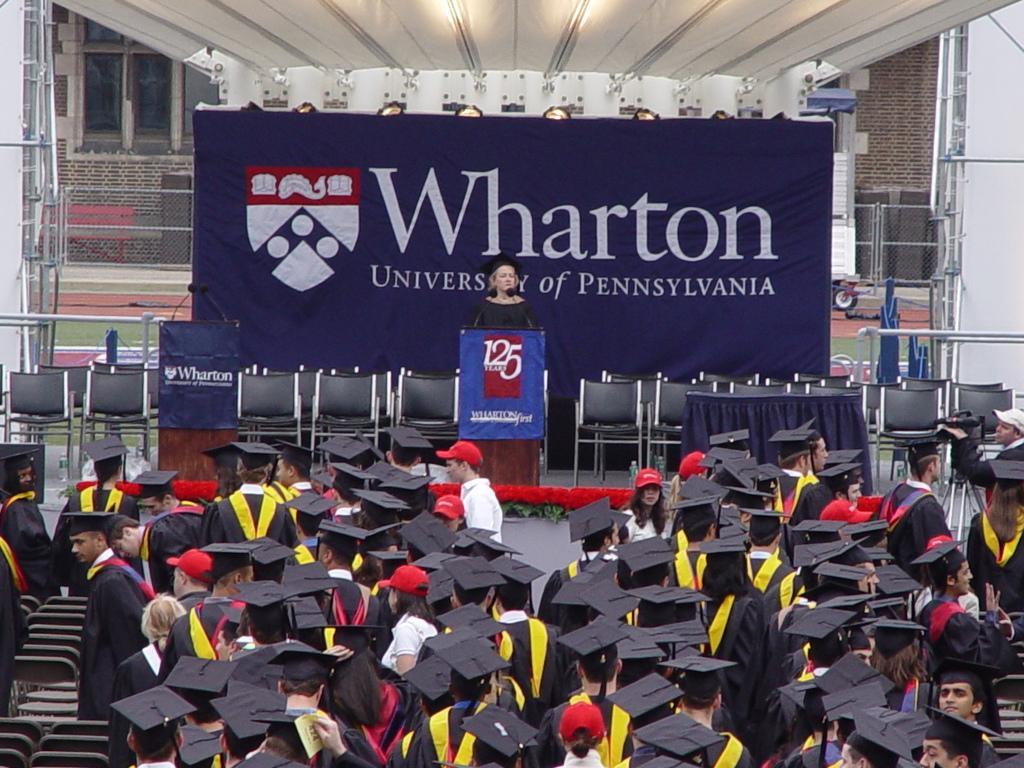Describe this image in one or two sentences. In this picture there are people at the bottom side of the image, they are wearing apron and there is a lady in the center of the image, in front of a deck and there is a mic on the desk, there are empty chairs in the center of the image and there is a poster behind chairs and there is a building in the background area of the image and there are towers on the right and left side of the image. 